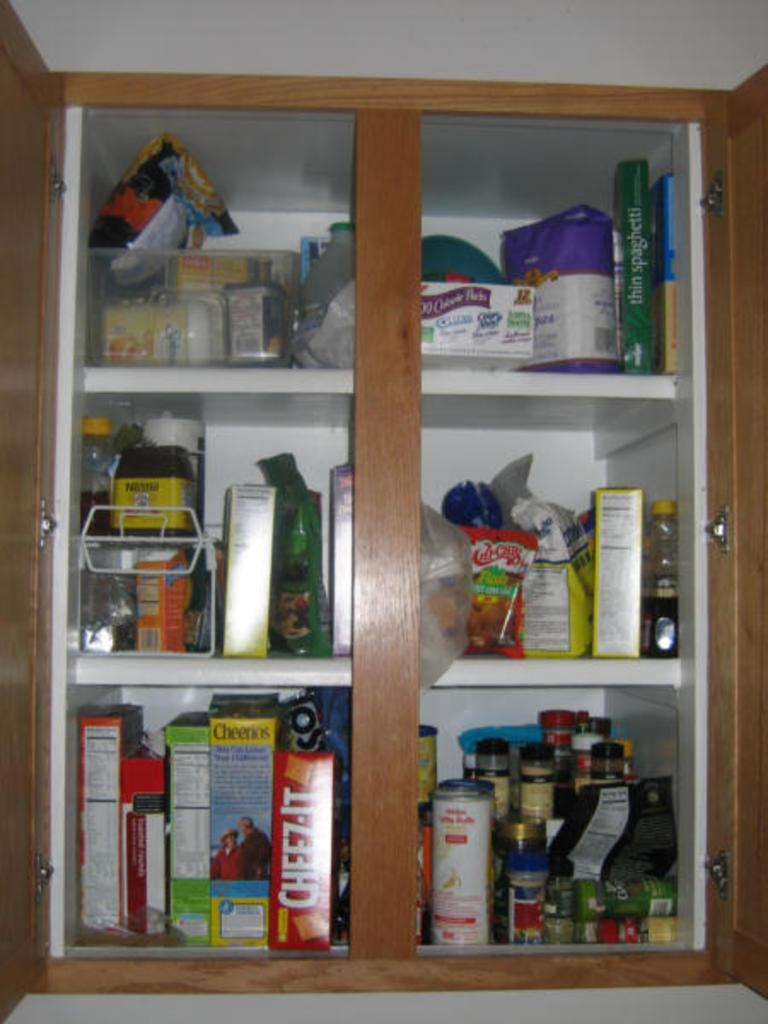What can be seen in the image? In the image, there are objects placed in racks. Can you describe the arrangement of the objects in the image? The objects are placed in racks, which suggests they are organized and stored in a specific manner. What type of grass can be seen growing in the image? There is no grass present in the image; it only shows objects placed in racks. 